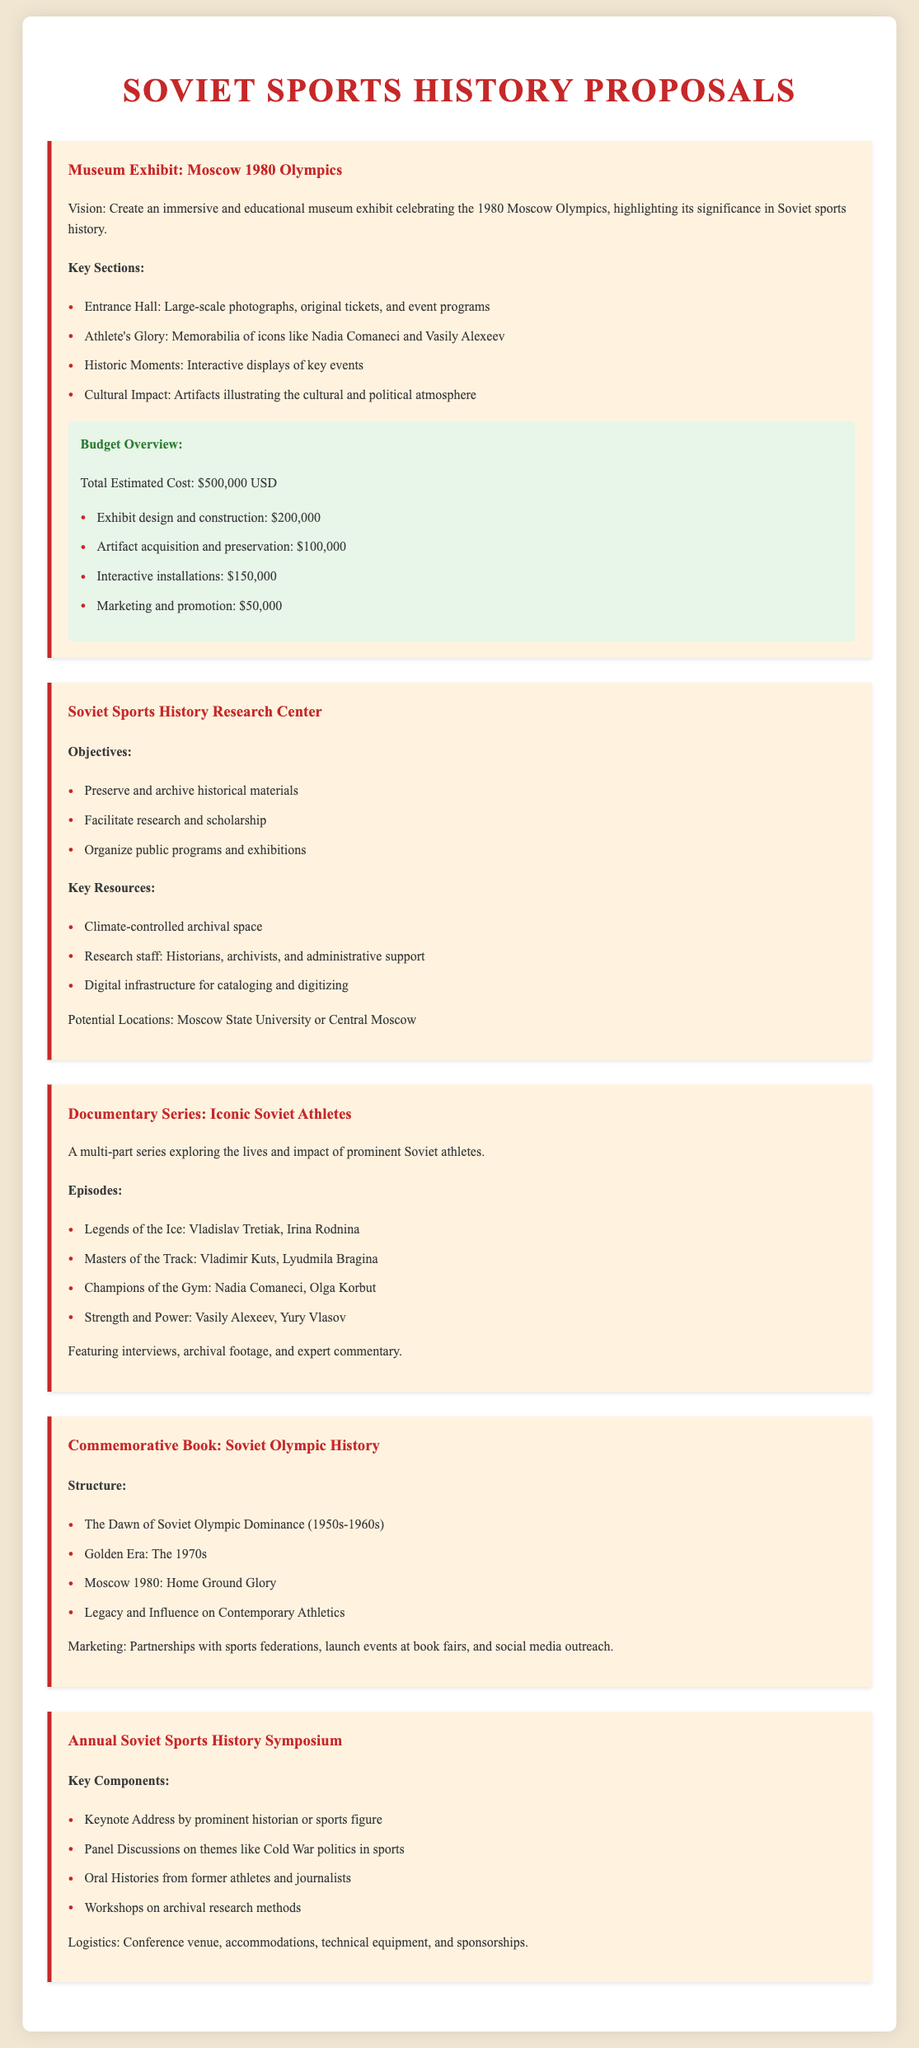What is the total estimated cost for the museum exhibit? The total estimated cost is specifically listed in the budget overview section of the document.
Answer: $500,000 USD What is included in the "Athlete's Glory" section of the exhibit? This section lists specific memorabilia relating to iconic athletes, highlighted in the key sections of the proposal.
Answer: Memorabilia of icons like Nadia Comaneci and Vasily Alexeev What key resources are needed for the Soviet Sports History Research Center? The document enumerates the resources critical for the center's operation under the key resources heading.
Answer: Climate-controlled archival space Which athletes are featured in the documentary series? The episodes section includes specific athletes associated with different sports highlighted in the proposed documentary.
Answer: Vladislav Tretiak, Irina Rodnina, Vladimir Kuts, Lyudmila Bragina, Nadia Comaneci, Olga Korbut, Vasily Alexeev, Yury Vlasov What is the focus of the Annual Soviet Sports History Symposium? The document outlines the primary components of the symposium, reflecting its main focus as stated in the key components section.
Answer: Themes like Cold War politics in sports How many main sections does the commemorative book cover? The structure section explicitly lists the main sections of the book, indicating the total number of sections presented.
Answer: Four sections 